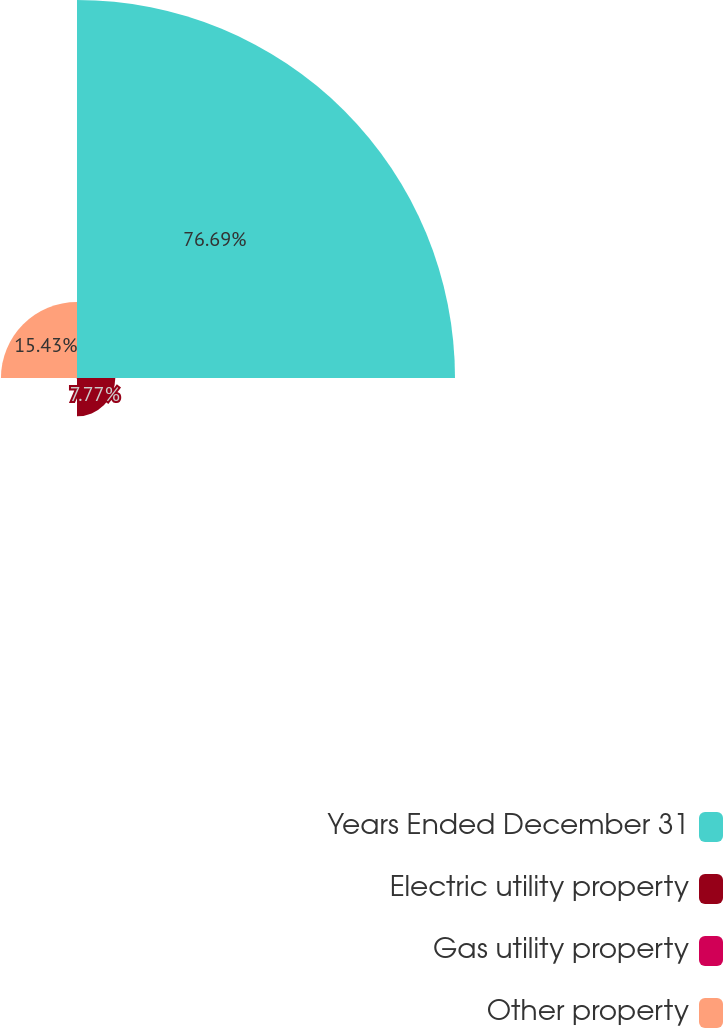<chart> <loc_0><loc_0><loc_500><loc_500><pie_chart><fcel>Years Ended December 31<fcel>Electric utility property<fcel>Gas utility property<fcel>Other property<nl><fcel>76.69%<fcel>7.77%<fcel>0.11%<fcel>15.43%<nl></chart> 